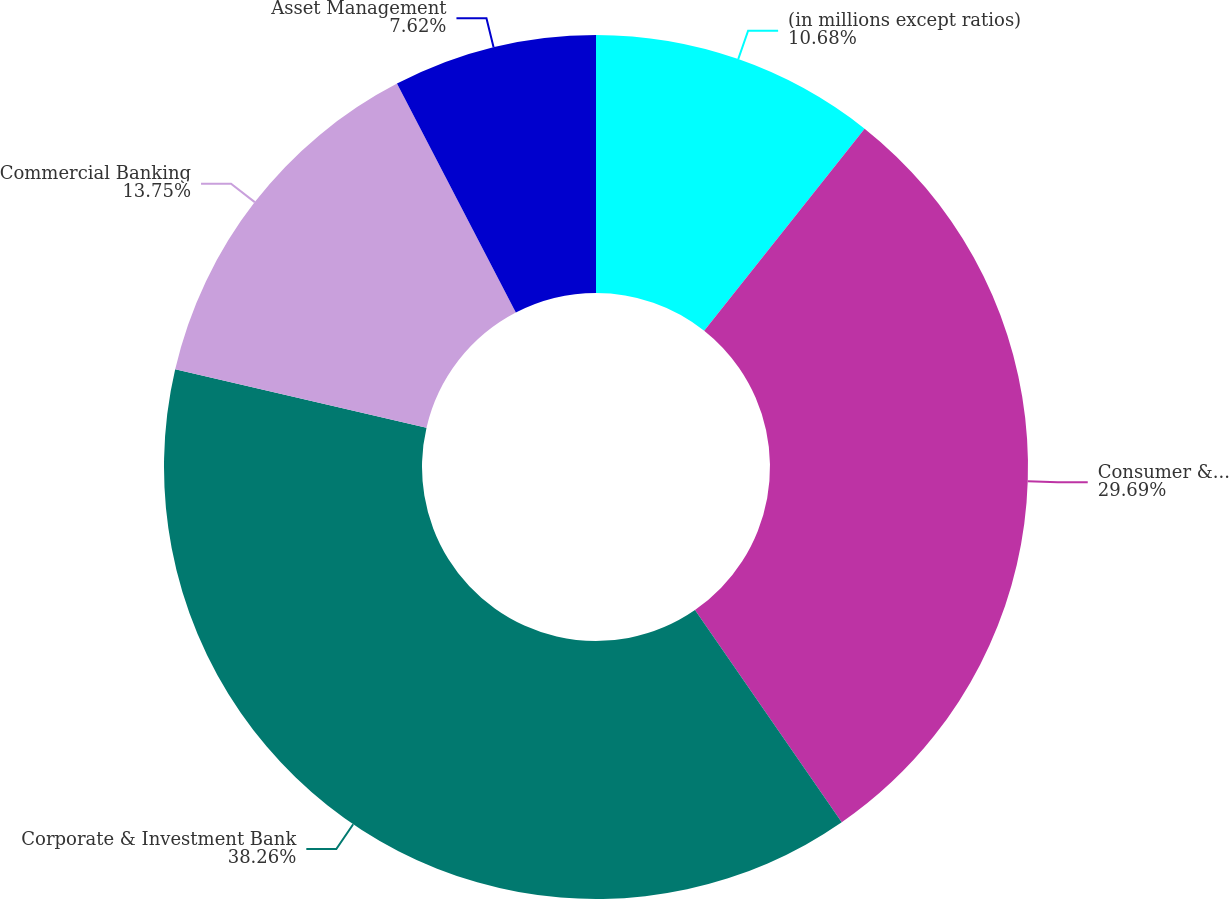<chart> <loc_0><loc_0><loc_500><loc_500><pie_chart><fcel>(in millions except ratios)<fcel>Consumer & Community Banking<fcel>Corporate & Investment Bank<fcel>Commercial Banking<fcel>Asset Management<nl><fcel>10.68%<fcel>29.69%<fcel>38.26%<fcel>13.75%<fcel>7.62%<nl></chart> 